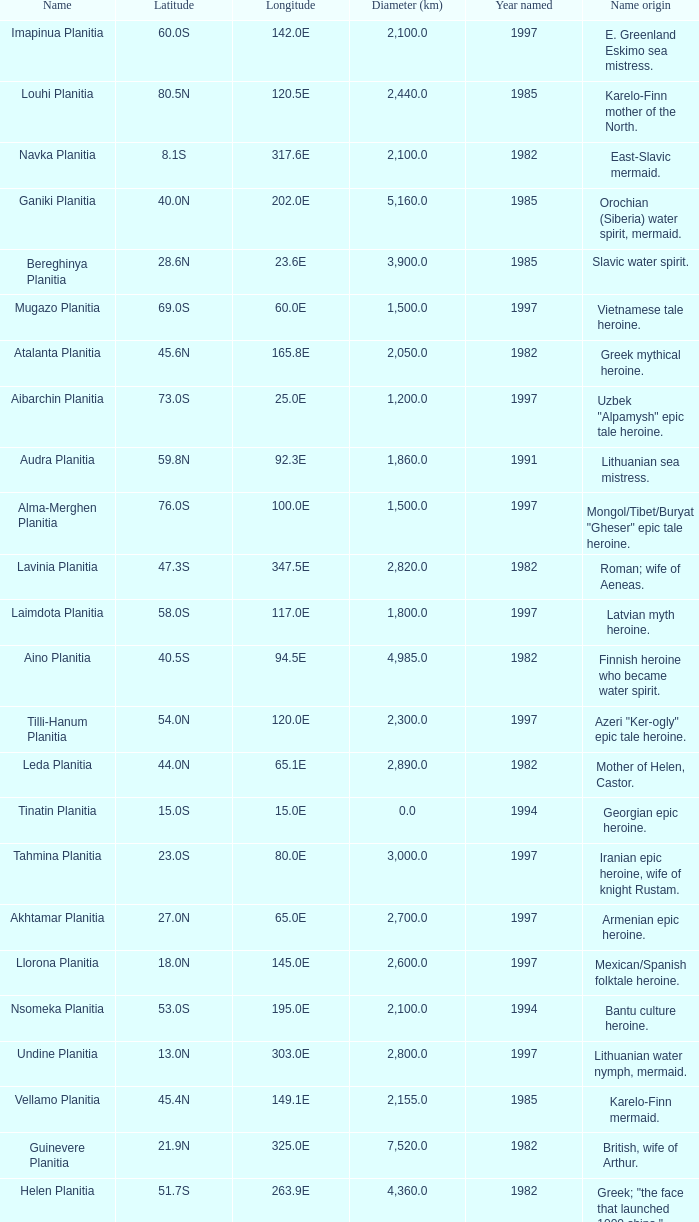What is the latitude of the feature of longitude 80.0e 23.0S. 